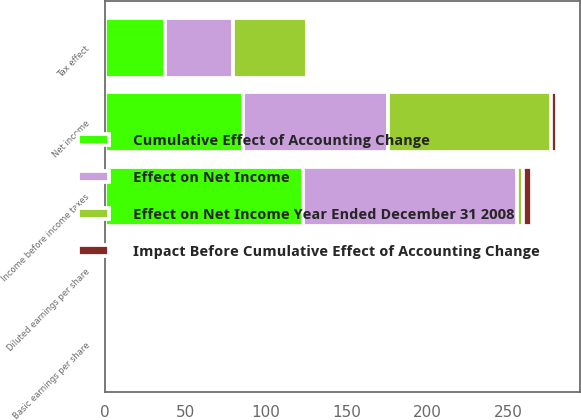<chart> <loc_0><loc_0><loc_500><loc_500><stacked_bar_chart><ecel><fcel>Income before income taxes<fcel>Tax effect<fcel>Net income<fcel>Basic earnings per share<fcel>Diluted earnings per share<nl><fcel>Effect on Net Income Year Ended December 31 2008<fcel>3.8<fcel>45.4<fcel>100.8<fcel>0.34<fcel>0.34<nl><fcel>Cumulative Effect of Accounting Change<fcel>123.1<fcel>37.5<fcel>85.6<fcel>0.27<fcel>0.27<nl><fcel>Effect on Net Income<fcel>132.4<fcel>42.3<fcel>90.1<fcel>0.27<fcel>0.26<nl><fcel>Impact Before Cumulative Effect of Accounting Change<fcel>5.6<fcel>1.8<fcel>3.8<fcel>0.01<fcel>0.01<nl></chart> 